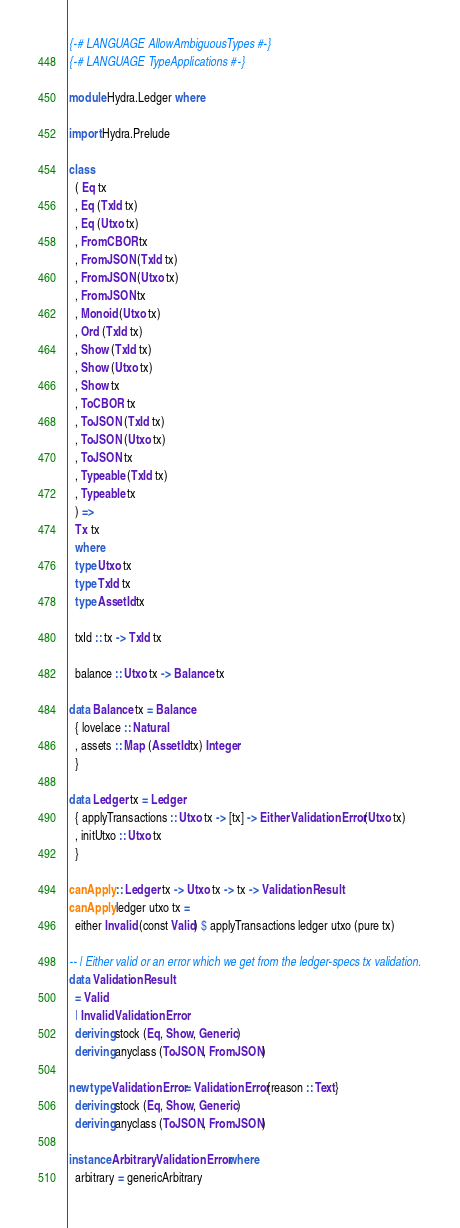Convert code to text. <code><loc_0><loc_0><loc_500><loc_500><_Haskell_>{-# LANGUAGE AllowAmbiguousTypes #-}
{-# LANGUAGE TypeApplications #-}

module Hydra.Ledger where

import Hydra.Prelude

class
  ( Eq tx
  , Eq (TxId tx)
  , Eq (Utxo tx)
  , FromCBOR tx
  , FromJSON (TxId tx)
  , FromJSON (Utxo tx)
  , FromJSON tx
  , Monoid (Utxo tx)
  , Ord (TxId tx)
  , Show (TxId tx)
  , Show (Utxo tx)
  , Show tx
  , ToCBOR tx
  , ToJSON (TxId tx)
  , ToJSON (Utxo tx)
  , ToJSON tx
  , Typeable (TxId tx)
  , Typeable tx
  ) =>
  Tx tx
  where
  type Utxo tx
  type TxId tx
  type AssetId tx

  txId :: tx -> TxId tx

  balance :: Utxo tx -> Balance tx

data Balance tx = Balance
  { lovelace :: Natural
  , assets :: Map (AssetId tx) Integer
  }

data Ledger tx = Ledger
  { applyTransactions :: Utxo tx -> [tx] -> Either ValidationError (Utxo tx)
  , initUtxo :: Utxo tx
  }

canApply :: Ledger tx -> Utxo tx -> tx -> ValidationResult
canApply ledger utxo tx =
  either Invalid (const Valid) $ applyTransactions ledger utxo (pure tx)

-- | Either valid or an error which we get from the ledger-specs tx validation.
data ValidationResult
  = Valid
  | Invalid ValidationError
  deriving stock (Eq, Show, Generic)
  deriving anyclass (ToJSON, FromJSON)

newtype ValidationError = ValidationError {reason :: Text}
  deriving stock (Eq, Show, Generic)
  deriving anyclass (ToJSON, FromJSON)

instance Arbitrary ValidationError where
  arbitrary = genericArbitrary
</code> 